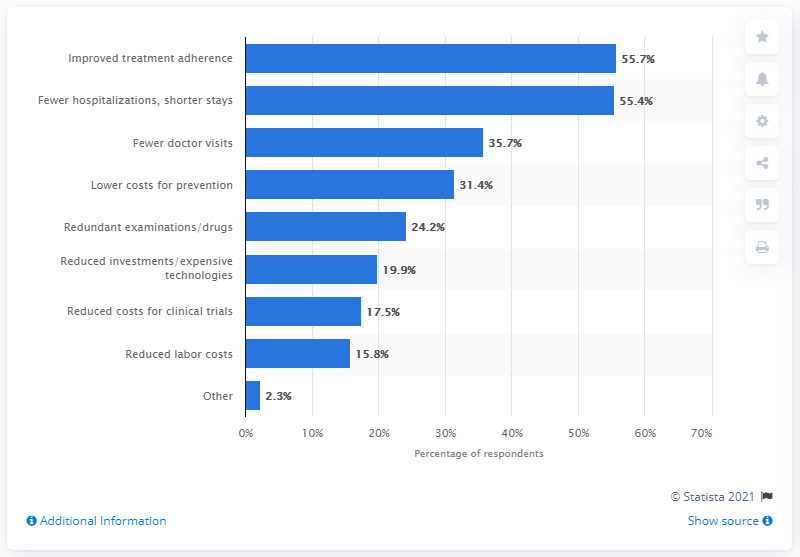What percentage of respondents stated fewer doctor visits as a potential cost saving? According to the chart provided, 35.7% of respondents believe that fewer doctor visits could result in potential cost savings. This information highlights a significant portion of the surveyed group recognizing direct healthcare savings from reduced physician consultations. 